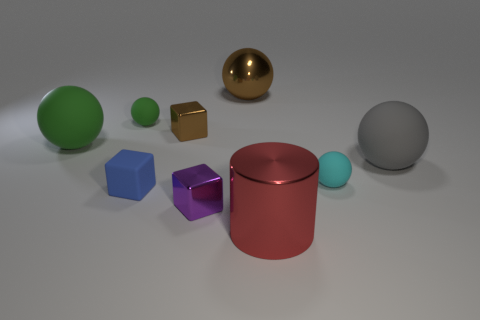Are there any small rubber spheres that are in front of the big matte thing that is right of the small sphere to the right of the red metallic cylinder?
Give a very brief answer. Yes. Is the number of brown objects greater than the number of balls?
Offer a very short reply. No. There is a tiny matte sphere on the right side of the blue rubber cube; what color is it?
Your answer should be compact. Cyan. Is the number of blocks that are on the right side of the brown sphere greater than the number of small blue cubes?
Provide a short and direct response. No. Is the material of the tiny purple thing the same as the small brown object?
Ensure brevity in your answer.  Yes. What number of other things are the same shape as the small purple thing?
Make the answer very short. 2. The tiny rubber ball left of the tiny matte object that is on the right side of the object in front of the tiny purple cube is what color?
Give a very brief answer. Green. There is a large metal thing that is in front of the big brown shiny object; is it the same shape as the gray thing?
Ensure brevity in your answer.  No. What number of cubes are there?
Give a very brief answer. 3. How many green rubber spheres have the same size as the brown metal cube?
Ensure brevity in your answer.  1. 